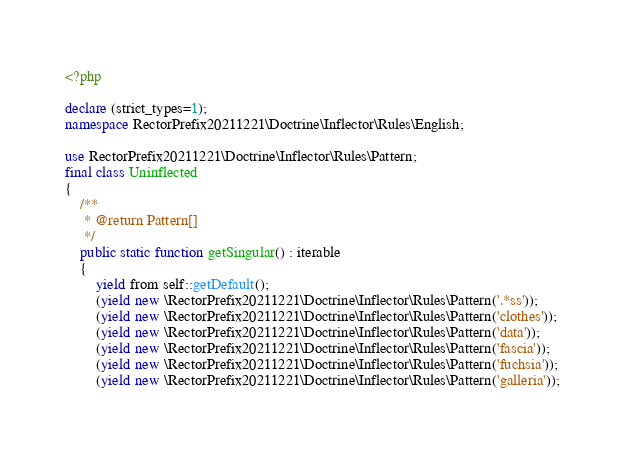Convert code to text. <code><loc_0><loc_0><loc_500><loc_500><_PHP_><?php

declare (strict_types=1);
namespace RectorPrefix20211221\Doctrine\Inflector\Rules\English;

use RectorPrefix20211221\Doctrine\Inflector\Rules\Pattern;
final class Uninflected
{
    /**
     * @return Pattern[]
     */
    public static function getSingular() : iterable
    {
        yield from self::getDefault();
        (yield new \RectorPrefix20211221\Doctrine\Inflector\Rules\Pattern('.*ss'));
        (yield new \RectorPrefix20211221\Doctrine\Inflector\Rules\Pattern('clothes'));
        (yield new \RectorPrefix20211221\Doctrine\Inflector\Rules\Pattern('data'));
        (yield new \RectorPrefix20211221\Doctrine\Inflector\Rules\Pattern('fascia'));
        (yield new \RectorPrefix20211221\Doctrine\Inflector\Rules\Pattern('fuchsia'));
        (yield new \RectorPrefix20211221\Doctrine\Inflector\Rules\Pattern('galleria'));</code> 